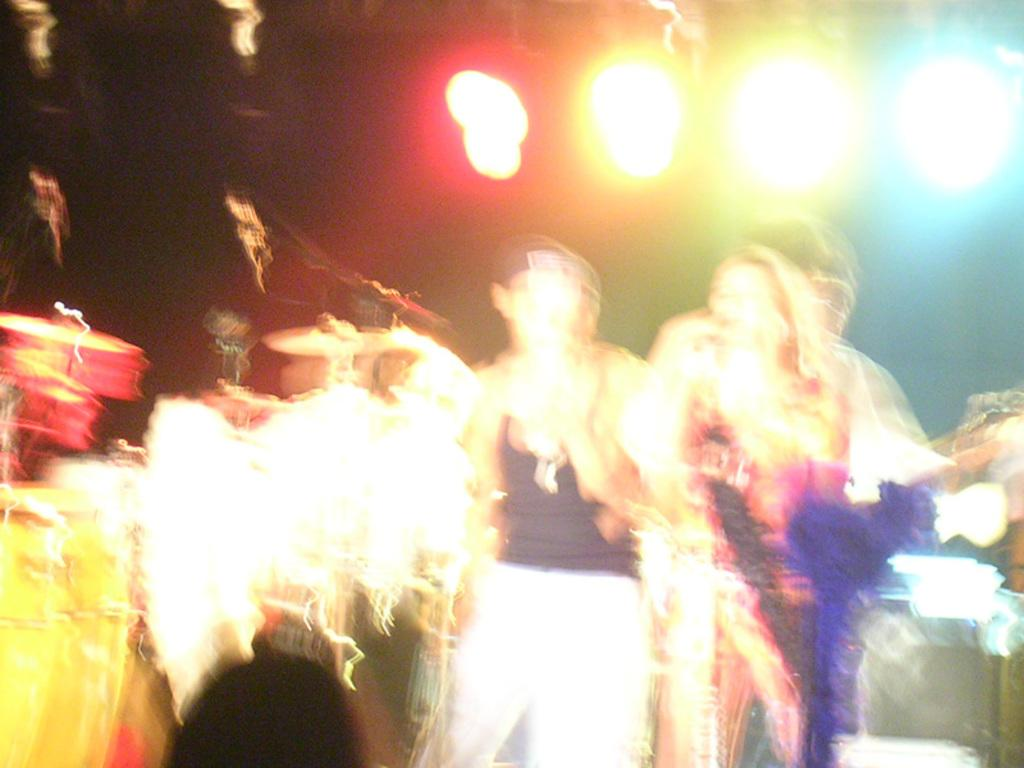Who or what can be seen in the image? There are people in the image. What are the people doing in the image? The people are likely playing musical instruments, as they are visible in the image. What else can be seen in the image besides the people? Colorful lights are visible at the top of the image. Where is the sheep sitting in the image? There is no sheep present in the image. What type of locket is hanging from the musical instruments in the image? There is no locket present in the image. 